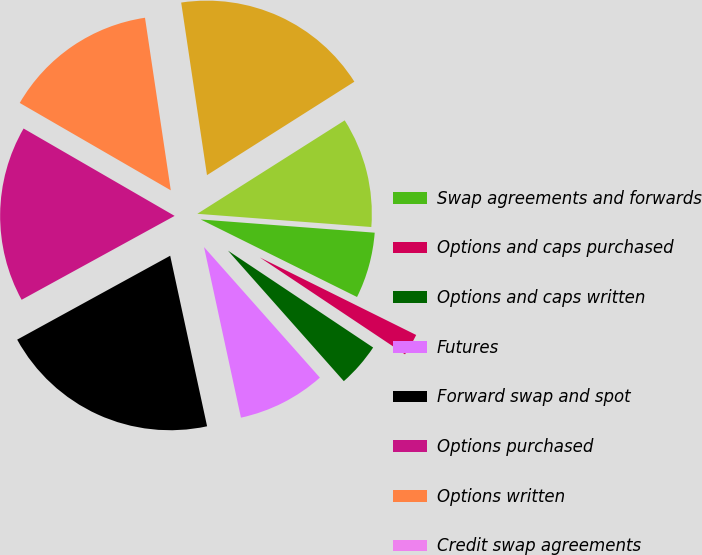Convert chart to OTSL. <chart><loc_0><loc_0><loc_500><loc_500><pie_chart><fcel>Swap agreements and forwards<fcel>Options and caps purchased<fcel>Options and caps written<fcel>Futures<fcel>Forward swap and spot<fcel>Options purchased<fcel>Options written<fcel>Credit swap agreements<fcel>Stable value contracts<fcel>Swap agreements<nl><fcel>6.12%<fcel>2.04%<fcel>4.08%<fcel>8.16%<fcel>20.41%<fcel>16.33%<fcel>14.29%<fcel>0.0%<fcel>18.37%<fcel>10.2%<nl></chart> 